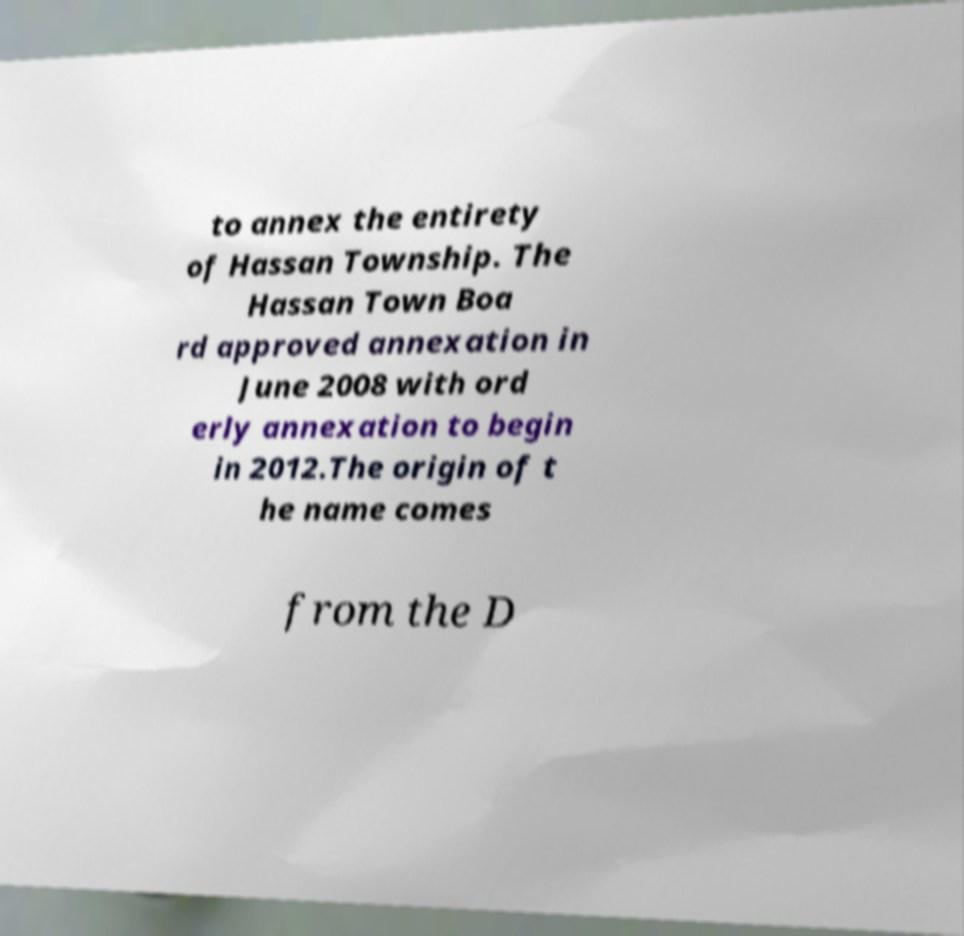I need the written content from this picture converted into text. Can you do that? to annex the entirety of Hassan Township. The Hassan Town Boa rd approved annexation in June 2008 with ord erly annexation to begin in 2012.The origin of t he name comes from the D 